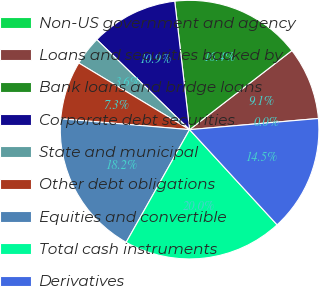Convert chart to OTSL. <chart><loc_0><loc_0><loc_500><loc_500><pie_chart><fcel>Non-US government and agency<fcel>Loans and securities backed by<fcel>Bank loans and bridge loans<fcel>Corporate debt securities<fcel>State and municipal<fcel>Other debt obligations<fcel>Equities and convertible<fcel>Total cash instruments<fcel>Derivatives<nl><fcel>0.01%<fcel>9.09%<fcel>16.36%<fcel>10.91%<fcel>3.64%<fcel>7.28%<fcel>18.18%<fcel>19.99%<fcel>14.54%<nl></chart> 